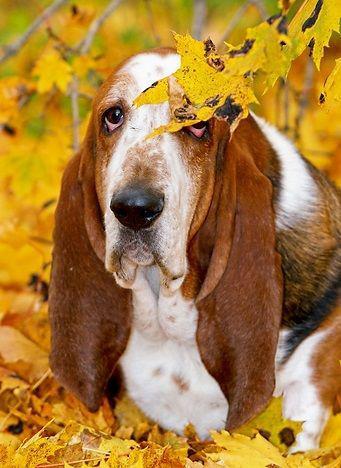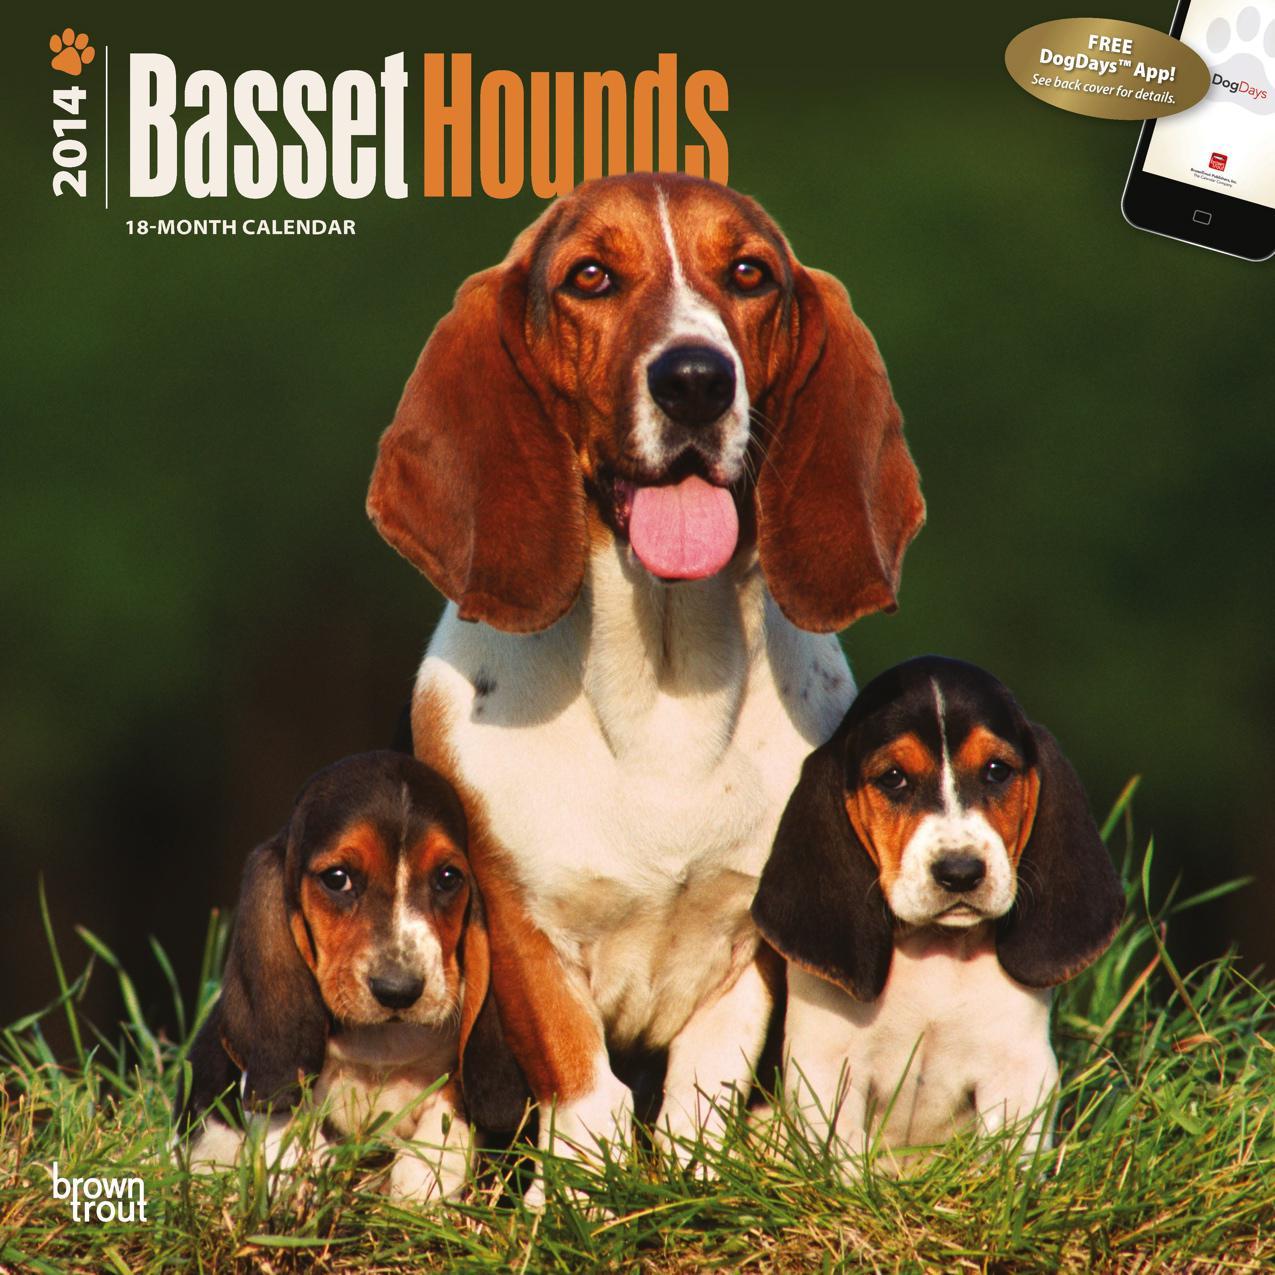The first image is the image on the left, the second image is the image on the right. Given the left and right images, does the statement "In one of the images, a basset hound is among colorful yellow leaves" hold true? Answer yes or no. Yes. The first image is the image on the left, the second image is the image on the right. Examine the images to the left and right. Is the description "There are three hounds in the right image." accurate? Answer yes or no. Yes. 